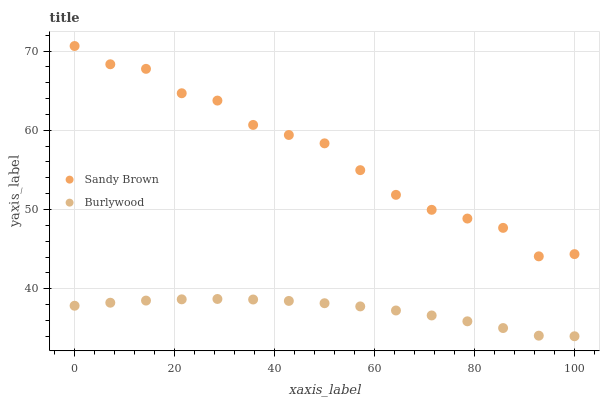Does Burlywood have the minimum area under the curve?
Answer yes or no. Yes. Does Sandy Brown have the maximum area under the curve?
Answer yes or no. Yes. Does Sandy Brown have the minimum area under the curve?
Answer yes or no. No. Is Burlywood the smoothest?
Answer yes or no. Yes. Is Sandy Brown the roughest?
Answer yes or no. Yes. Is Sandy Brown the smoothest?
Answer yes or no. No. Does Burlywood have the lowest value?
Answer yes or no. Yes. Does Sandy Brown have the lowest value?
Answer yes or no. No. Does Sandy Brown have the highest value?
Answer yes or no. Yes. Is Burlywood less than Sandy Brown?
Answer yes or no. Yes. Is Sandy Brown greater than Burlywood?
Answer yes or no. Yes. Does Burlywood intersect Sandy Brown?
Answer yes or no. No. 